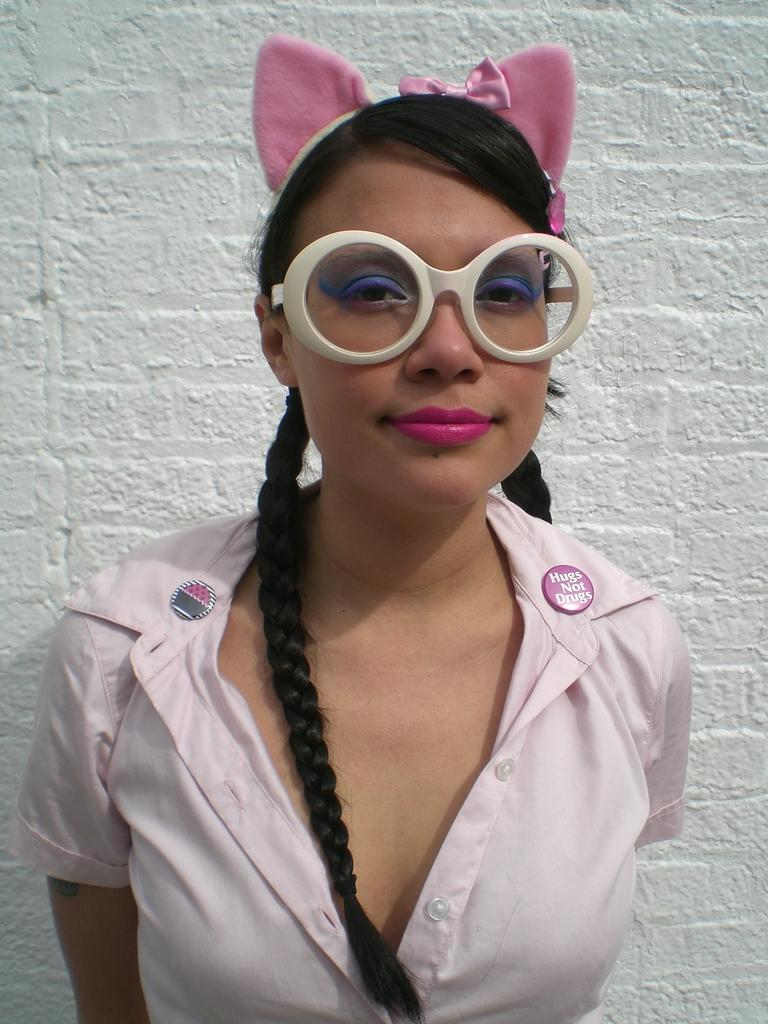Who is present in the image? There is a woman in the image. What is the woman wearing? The woman is wearing a dress, a headband, and spectacles. What is the woman's posture in the image? The woman is standing. What can be seen in the background of the image? There is a wall in the background of the image. What type of ink is the woman using to write on the wall in the image? There is no indication in the image that the woman is writing on the wall or using any ink. 